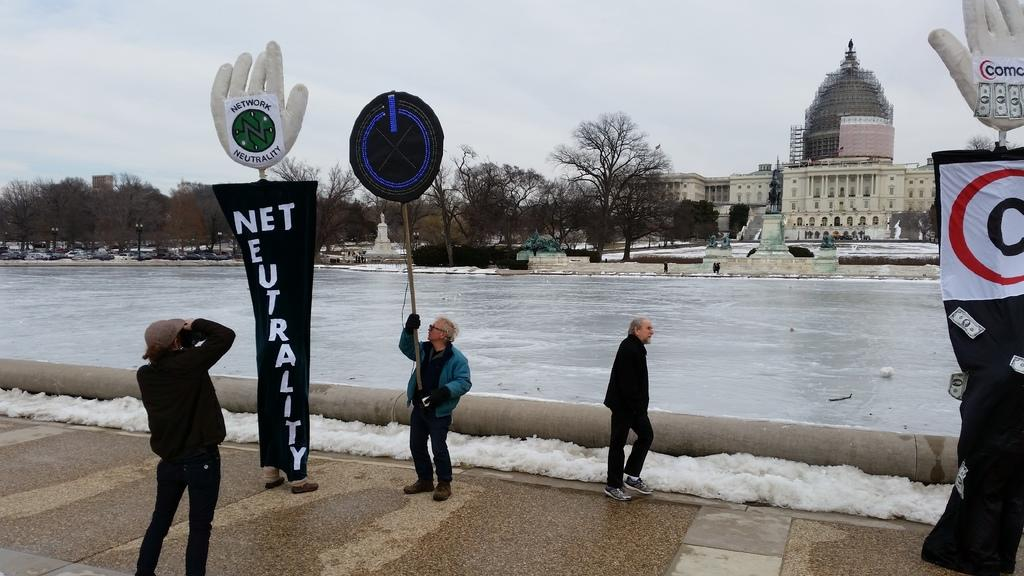<image>
Summarize the visual content of the image. a sign that says net neutrality on it 